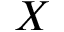Convert formula to latex. <formula><loc_0><loc_0><loc_500><loc_500>X</formula> 